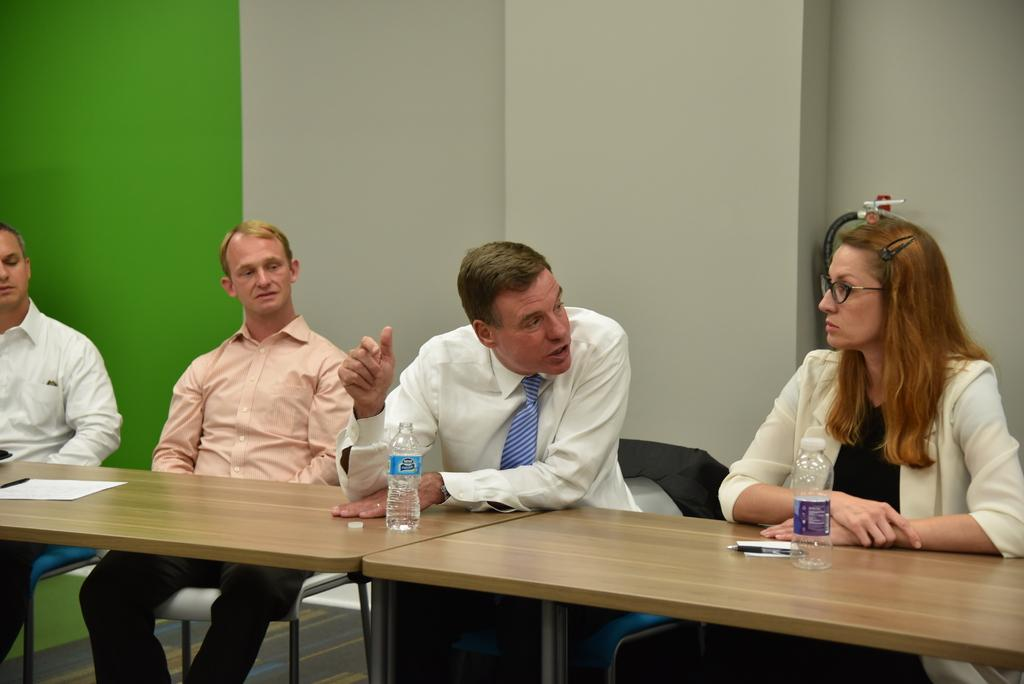What are the people in the image doing? The people in the image are sitting on chairs. What objects are placed in front of the chairs? Tables are placed in front of the chairs. What can be seen in the background of the image? There are walls, disposal bottles, paper, and pens visible in the background of the image. What type of flowers can be seen growing on the chairs in the image? There are no flowers visible on the chairs in the image. Can you tell me how many frogs are sitting on the tables in the image? There are no frogs present in the image; only people, chairs, and tables are visible. 